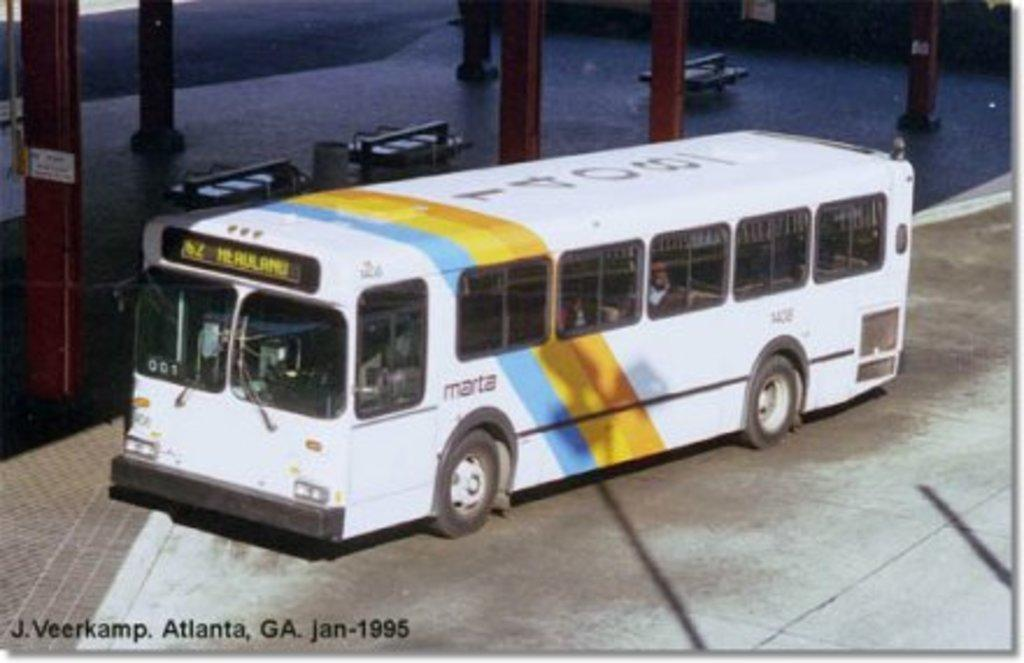<image>
Present a compact description of the photo's key features. A bus identified as MARTA on the side panel. 